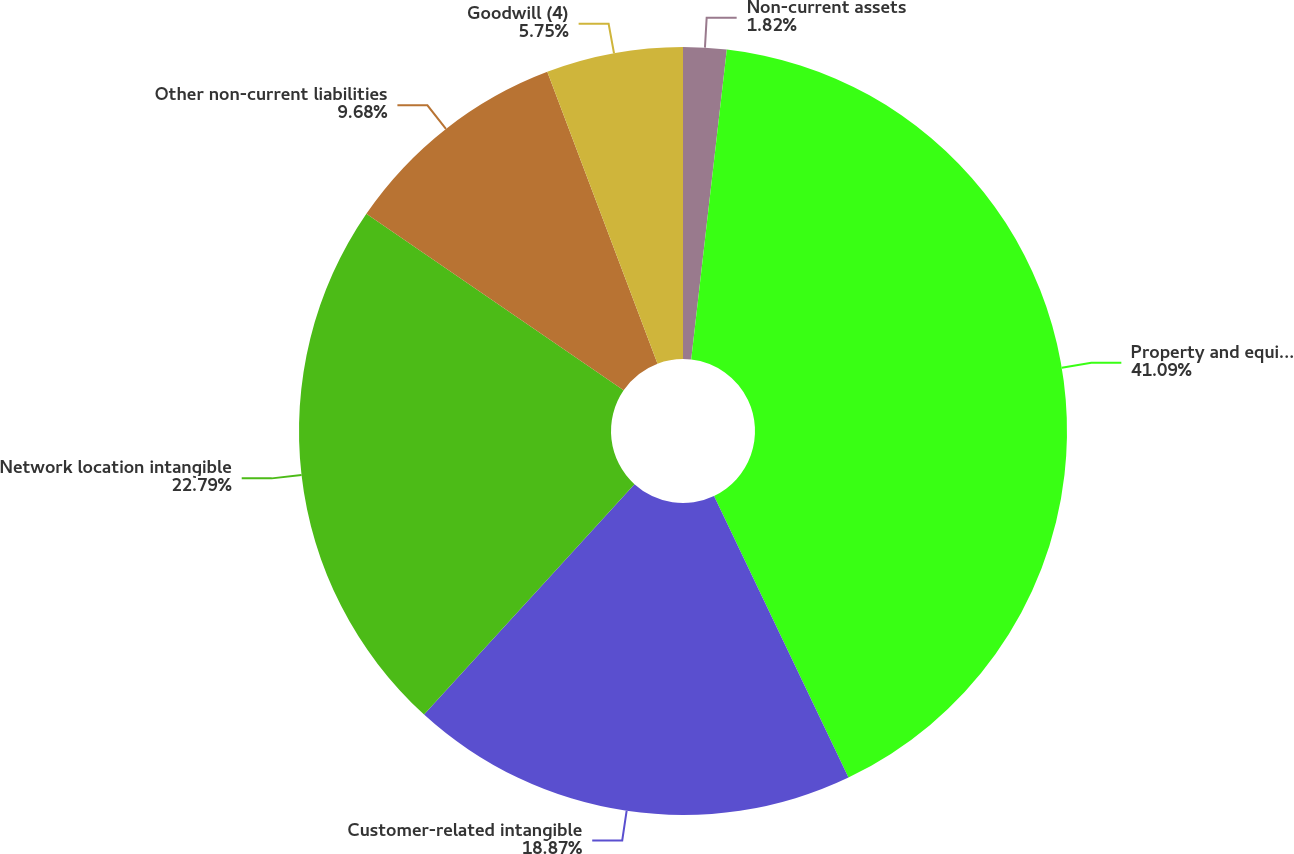Convert chart to OTSL. <chart><loc_0><loc_0><loc_500><loc_500><pie_chart><fcel>Non-current assets<fcel>Property and equipment<fcel>Customer-related intangible<fcel>Network location intangible<fcel>Other non-current liabilities<fcel>Goodwill (4)<nl><fcel>1.82%<fcel>41.09%<fcel>18.87%<fcel>22.79%<fcel>9.68%<fcel>5.75%<nl></chart> 